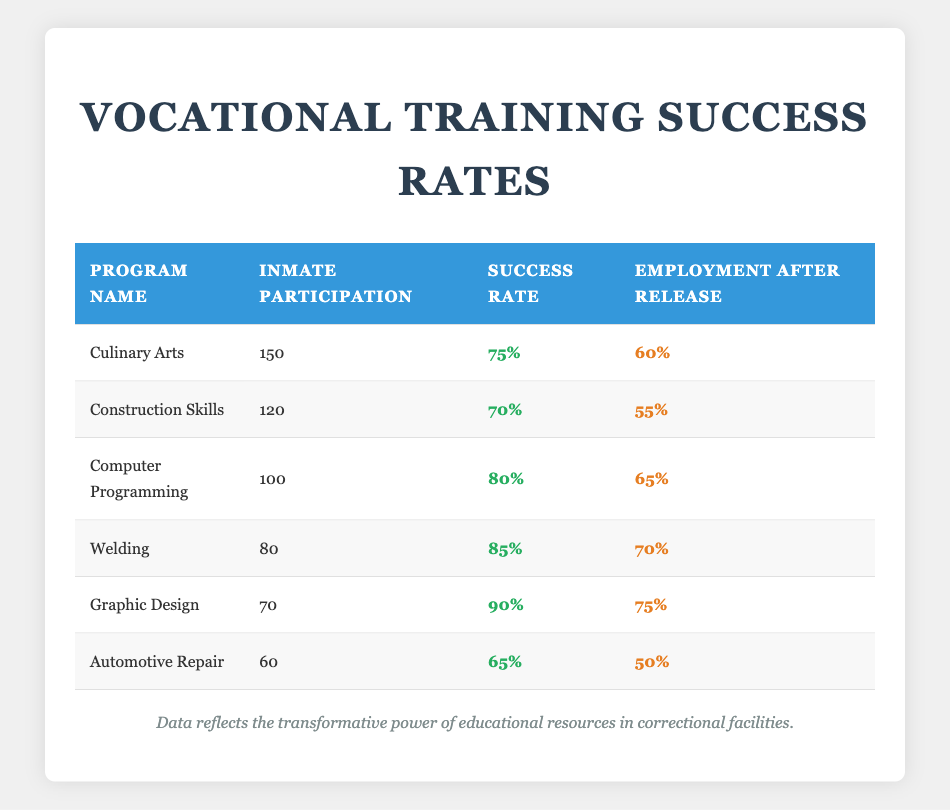What is the highest success rate among the vocational training programs? The success rates for each program are 75%, 70%, 80%, 85%, 90%, and 65%. The highest value is 90% from the Graphic Design program.
Answer: 90% How many inmates participated in the Welding program? The table indicates that 80 inmates participated in the Welding program. This is directly retrieved from the relevant row.
Answer: 80 Which program had the lowest employment rate after release? The employment rates after release for the programs are 60%, 55%, 65%, 70%, 75%, and 50%. The lowest of these is 50% from the Automotive Repair program.
Answer: 50% What is the combined success rate for the Culinary Arts and Automotive Repair programs? The success rates for Culinary Arts and Automotive Repair are 75% and 65%, respectively. Adding these gives 75 + 65 = 140, which we can average by dividing by 2: 140 / 2 = 70%.
Answer: 70% If you combine the inmate participation of all programs, how many inmates participated? Summing the inmate participation for all programs gives: 150 + 120 + 100 + 80 + 70 + 60 = 580. Thus, the total number of inmates that participated across all programs is 580.
Answer: 580 Is it true that more inmates participated in the Computer Programming program than the Construction Skills program? The Computer Programming program had 100 participants, while the Construction Skills program had 120 participants. Therefore, it is false that more inmates participated in Computer Programming.
Answer: No Which program had a success rate greater than 80% and an employment rate lower than 70%? The Welding program had a success rate of 85% and an employment rate of 70%, and the Automotive Repair program had a success rate of 65% and an employment rate of 50%. However, the only program that fits the criteria of having a success rate greater than 80% while having an employment rate lower than 70% is the Welding program (since it has exactly 70%).
Answer: None What is the difference in success rates between the program with the highest success rate and the program with the lowest success rate? The highest success rate is 90% (Graphic Design) and the lowest success rate is 65% (Automotive Repair). The difference is calculated as 90 - 65 = 25%.
Answer: 25% What percentage of inmates who participated in the Welding program found employment after release? The Welding program had 80 participants and showed an employment rate of 70%. This implies that 70% of the 80 inmates who participated found employment after release.
Answer: 70% 